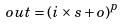Convert formula to latex. <formula><loc_0><loc_0><loc_500><loc_500>o u t = ( i \times s + o ) ^ { p }</formula> 